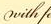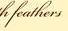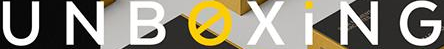What text appears in these images from left to right, separated by a semicolon? with; feathers; UNBOXiNG 